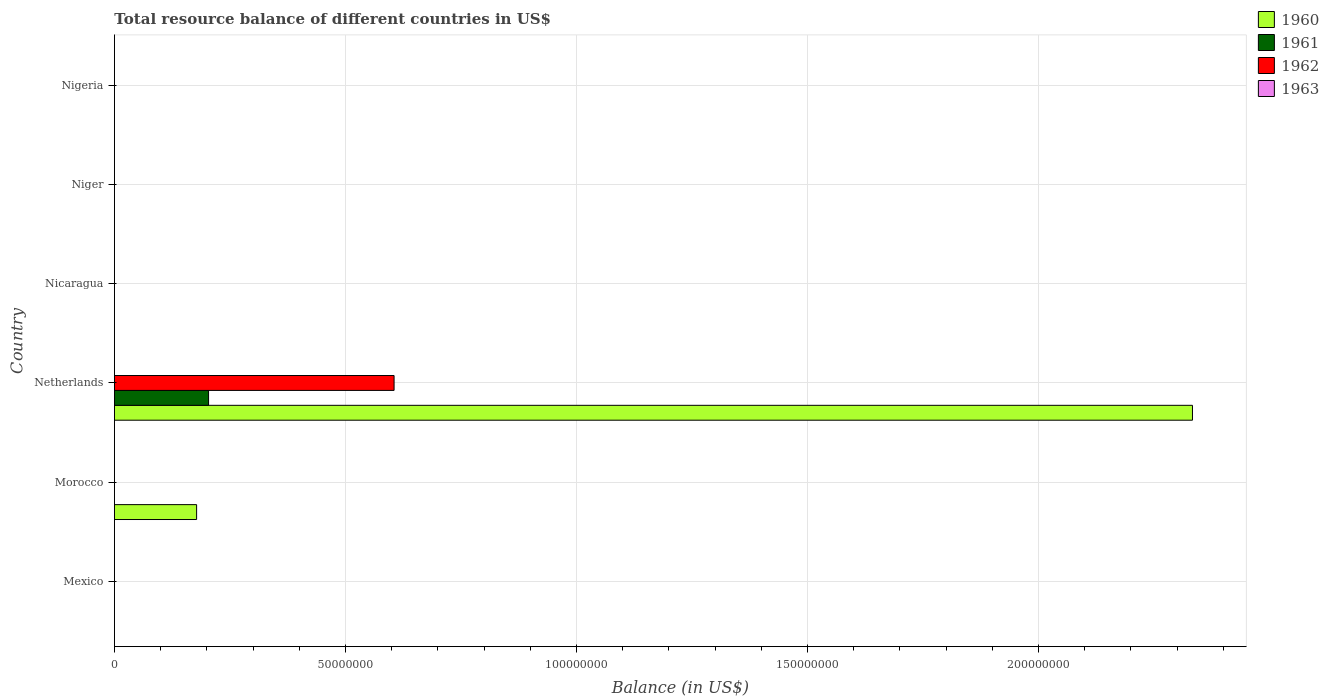How many different coloured bars are there?
Give a very brief answer. 3. Are the number of bars per tick equal to the number of legend labels?
Provide a succinct answer. No. Are the number of bars on each tick of the Y-axis equal?
Keep it short and to the point. No. How many bars are there on the 3rd tick from the top?
Ensure brevity in your answer.  0. What is the label of the 4th group of bars from the top?
Your answer should be very brief. Netherlands. In how many cases, is the number of bars for a given country not equal to the number of legend labels?
Make the answer very short. 6. What is the total resource balance in 1961 in Netherlands?
Offer a very short reply. 2.04e+07. Across all countries, what is the maximum total resource balance in 1961?
Keep it short and to the point. 2.04e+07. What is the total total resource balance in 1961 in the graph?
Give a very brief answer. 2.04e+07. What is the difference between the total resource balance in 1961 in Morocco and the total resource balance in 1963 in Netherlands?
Your response must be concise. 0. What is the average total resource balance in 1963 per country?
Offer a very short reply. 0. What is the difference between the total resource balance in 1962 and total resource balance in 1961 in Netherlands?
Offer a terse response. 4.01e+07. In how many countries, is the total resource balance in 1962 greater than 180000000 US$?
Offer a terse response. 0. What is the difference between the highest and the lowest total resource balance in 1961?
Make the answer very short. 2.04e+07. In how many countries, is the total resource balance in 1960 greater than the average total resource balance in 1960 taken over all countries?
Make the answer very short. 1. Are all the bars in the graph horizontal?
Make the answer very short. Yes. What is the difference between two consecutive major ticks on the X-axis?
Offer a very short reply. 5.00e+07. Are the values on the major ticks of X-axis written in scientific E-notation?
Provide a short and direct response. No. Does the graph contain any zero values?
Your answer should be compact. Yes. Does the graph contain grids?
Provide a short and direct response. Yes. How many legend labels are there?
Your answer should be compact. 4. What is the title of the graph?
Your response must be concise. Total resource balance of different countries in US$. What is the label or title of the X-axis?
Make the answer very short. Balance (in US$). What is the label or title of the Y-axis?
Your response must be concise. Country. What is the Balance (in US$) in 1960 in Morocco?
Offer a very short reply. 1.78e+07. What is the Balance (in US$) in 1961 in Morocco?
Provide a short and direct response. 0. What is the Balance (in US$) in 1962 in Morocco?
Keep it short and to the point. 0. What is the Balance (in US$) in 1963 in Morocco?
Ensure brevity in your answer.  0. What is the Balance (in US$) of 1960 in Netherlands?
Provide a short and direct response. 2.33e+08. What is the Balance (in US$) of 1961 in Netherlands?
Offer a very short reply. 2.04e+07. What is the Balance (in US$) of 1962 in Netherlands?
Your response must be concise. 6.05e+07. What is the Balance (in US$) in 1963 in Netherlands?
Give a very brief answer. 0. What is the Balance (in US$) in 1960 in Nicaragua?
Your response must be concise. 0. What is the Balance (in US$) in 1961 in Nicaragua?
Give a very brief answer. 0. What is the Balance (in US$) in 1962 in Nicaragua?
Your answer should be compact. 0. What is the Balance (in US$) of 1960 in Niger?
Provide a succinct answer. 0. What is the Balance (in US$) in 1961 in Nigeria?
Your response must be concise. 0. What is the Balance (in US$) of 1963 in Nigeria?
Offer a very short reply. 0. Across all countries, what is the maximum Balance (in US$) in 1960?
Offer a very short reply. 2.33e+08. Across all countries, what is the maximum Balance (in US$) in 1961?
Offer a terse response. 2.04e+07. Across all countries, what is the maximum Balance (in US$) of 1962?
Ensure brevity in your answer.  6.05e+07. Across all countries, what is the minimum Balance (in US$) of 1961?
Your answer should be very brief. 0. What is the total Balance (in US$) in 1960 in the graph?
Provide a short and direct response. 2.51e+08. What is the total Balance (in US$) in 1961 in the graph?
Ensure brevity in your answer.  2.04e+07. What is the total Balance (in US$) of 1962 in the graph?
Keep it short and to the point. 6.05e+07. What is the difference between the Balance (in US$) in 1960 in Morocco and that in Netherlands?
Keep it short and to the point. -2.16e+08. What is the difference between the Balance (in US$) in 1960 in Morocco and the Balance (in US$) in 1961 in Netherlands?
Your answer should be compact. -2.59e+06. What is the difference between the Balance (in US$) of 1960 in Morocco and the Balance (in US$) of 1962 in Netherlands?
Keep it short and to the point. -4.27e+07. What is the average Balance (in US$) in 1960 per country?
Offer a terse response. 4.18e+07. What is the average Balance (in US$) of 1961 per country?
Provide a succinct answer. 3.40e+06. What is the average Balance (in US$) of 1962 per country?
Keep it short and to the point. 1.01e+07. What is the difference between the Balance (in US$) of 1960 and Balance (in US$) of 1961 in Netherlands?
Keep it short and to the point. 2.13e+08. What is the difference between the Balance (in US$) in 1960 and Balance (in US$) in 1962 in Netherlands?
Offer a terse response. 1.73e+08. What is the difference between the Balance (in US$) in 1961 and Balance (in US$) in 1962 in Netherlands?
Ensure brevity in your answer.  -4.01e+07. What is the ratio of the Balance (in US$) in 1960 in Morocco to that in Netherlands?
Provide a succinct answer. 0.08. What is the difference between the highest and the lowest Balance (in US$) of 1960?
Your response must be concise. 2.33e+08. What is the difference between the highest and the lowest Balance (in US$) of 1961?
Keep it short and to the point. 2.04e+07. What is the difference between the highest and the lowest Balance (in US$) in 1962?
Keep it short and to the point. 6.05e+07. 